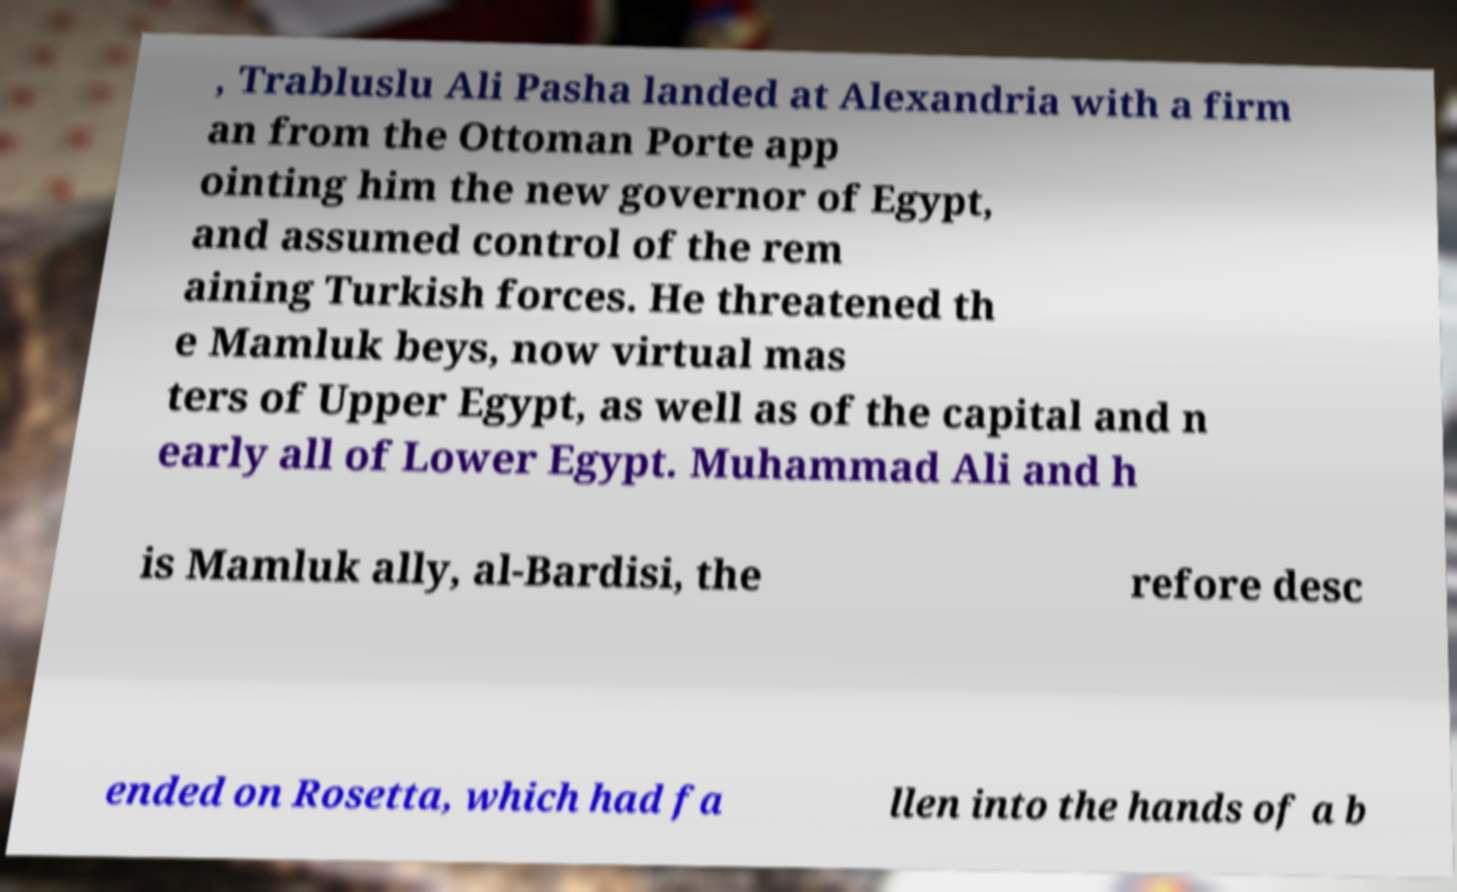Please identify and transcribe the text found in this image. , Trabluslu Ali Pasha landed at Alexandria with a firm an from the Ottoman Porte app ointing him the new governor of Egypt, and assumed control of the rem aining Turkish forces. He threatened th e Mamluk beys, now virtual mas ters of Upper Egypt, as well as of the capital and n early all of Lower Egypt. Muhammad Ali and h is Mamluk ally, al-Bardisi, the refore desc ended on Rosetta, which had fa llen into the hands of a b 